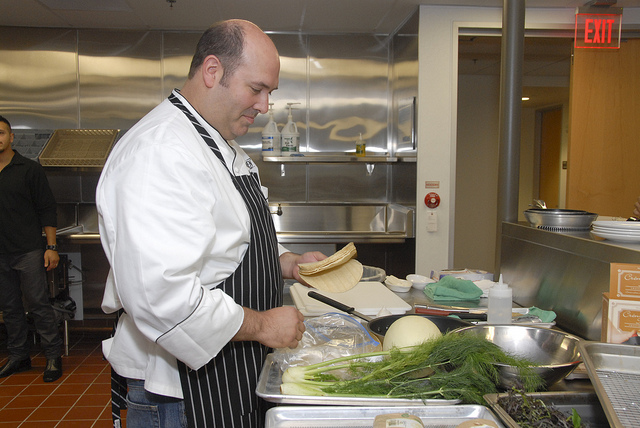<image>What green vegetables are being prepared? I am unsure what the green vegetables being prepared are. It could be broccoli, onions, leeks, fennel, bok choy, cilantro, or various herbs. What green vegetables are being prepared? I am not sure what green vegetables are being prepared. It can be seen broccoli, onions, leeks, fennel, bok choy, or cilantro. 